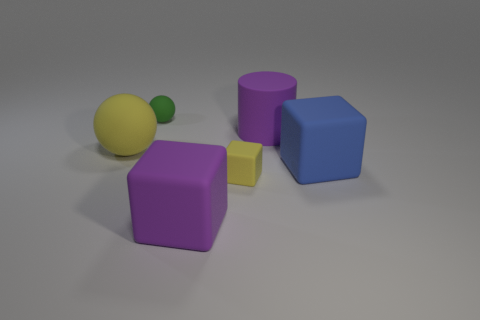There is a tiny thing to the right of the green matte thing; what is its material?
Offer a very short reply. Rubber. What size is the purple block that is the same material as the yellow sphere?
Keep it short and to the point. Large. What number of large yellow matte objects are the same shape as the green object?
Offer a very short reply. 1. There is a blue rubber object; is its shape the same as the purple object that is left of the purple cylinder?
Offer a terse response. Yes. There is a big thing that is the same color as the matte cylinder; what is its shape?
Your response must be concise. Cube. Is there a green ball made of the same material as the blue object?
Offer a terse response. Yes. There is a purple rubber thing behind the big purple block left of the tiny rubber object in front of the large rubber cylinder; what size is it?
Provide a succinct answer. Large. How many other things are there of the same shape as the tiny green rubber object?
Your response must be concise. 1. There is a big cube in front of the yellow matte block; is its color the same as the large rubber thing that is behind the yellow rubber ball?
Your answer should be compact. Yes. What is the color of the cylinder that is the same size as the purple rubber cube?
Your answer should be very brief. Purple. 